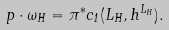Convert formula to latex. <formula><loc_0><loc_0><loc_500><loc_500>p \cdot \omega _ { H } = \pi ^ { * } c _ { 1 } ( L _ { H } , h ^ { L _ { H } } ) .</formula> 